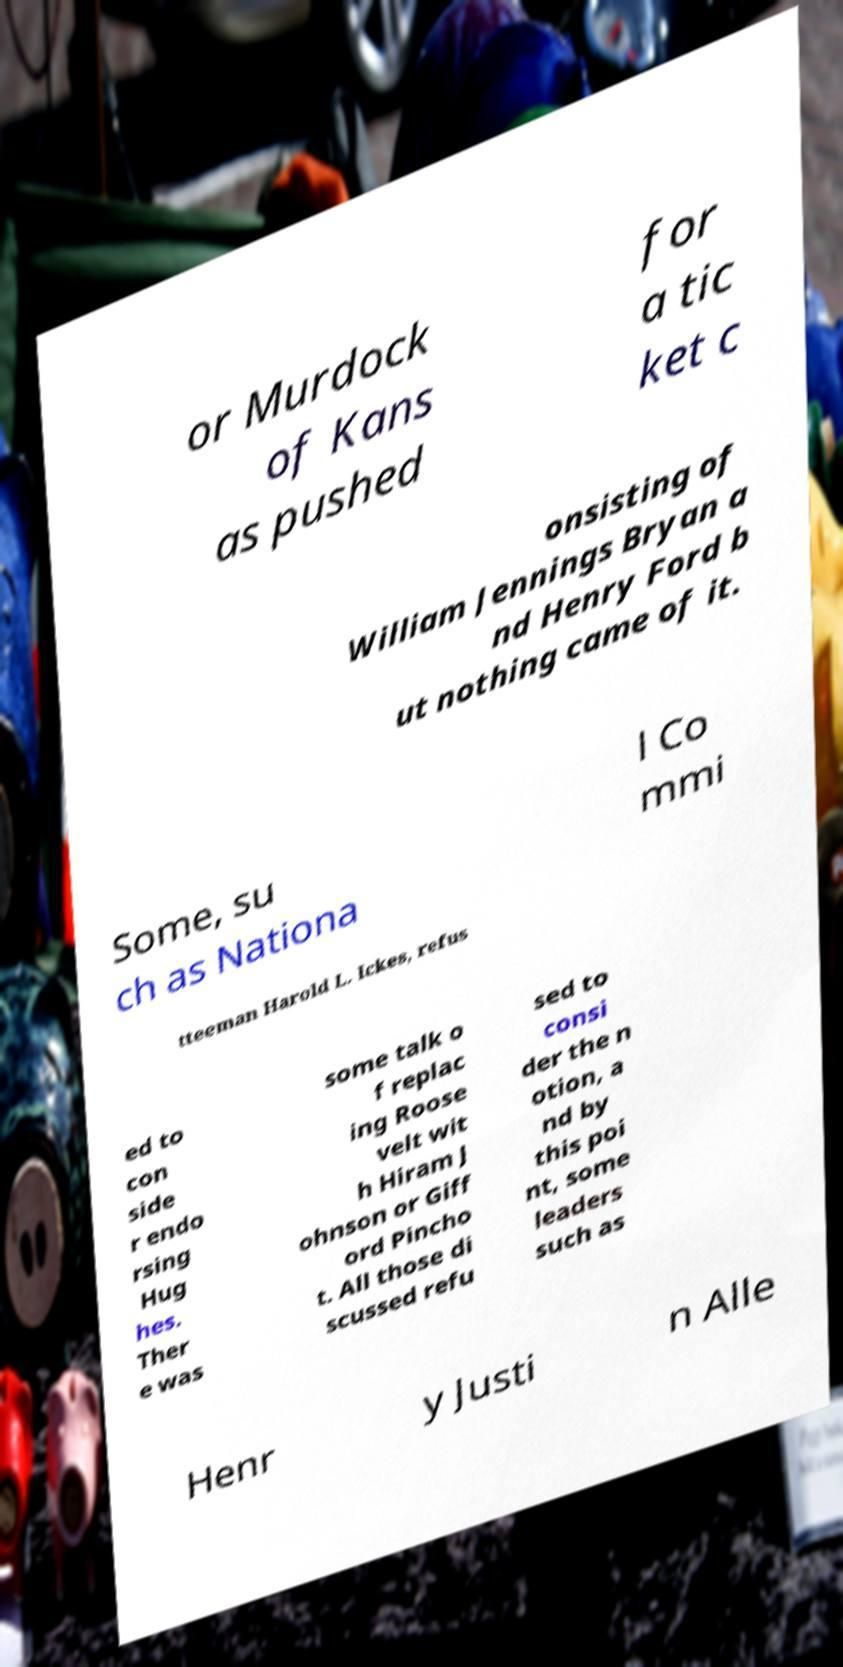Could you assist in decoding the text presented in this image and type it out clearly? or Murdock of Kans as pushed for a tic ket c onsisting of William Jennings Bryan a nd Henry Ford b ut nothing came of it. Some, su ch as Nationa l Co mmi tteeman Harold L. Ickes, refus ed to con side r endo rsing Hug hes. Ther e was some talk o f replac ing Roose velt wit h Hiram J ohnson or Giff ord Pincho t. All those di scussed refu sed to consi der the n otion, a nd by this poi nt, some leaders such as Henr y Justi n Alle 